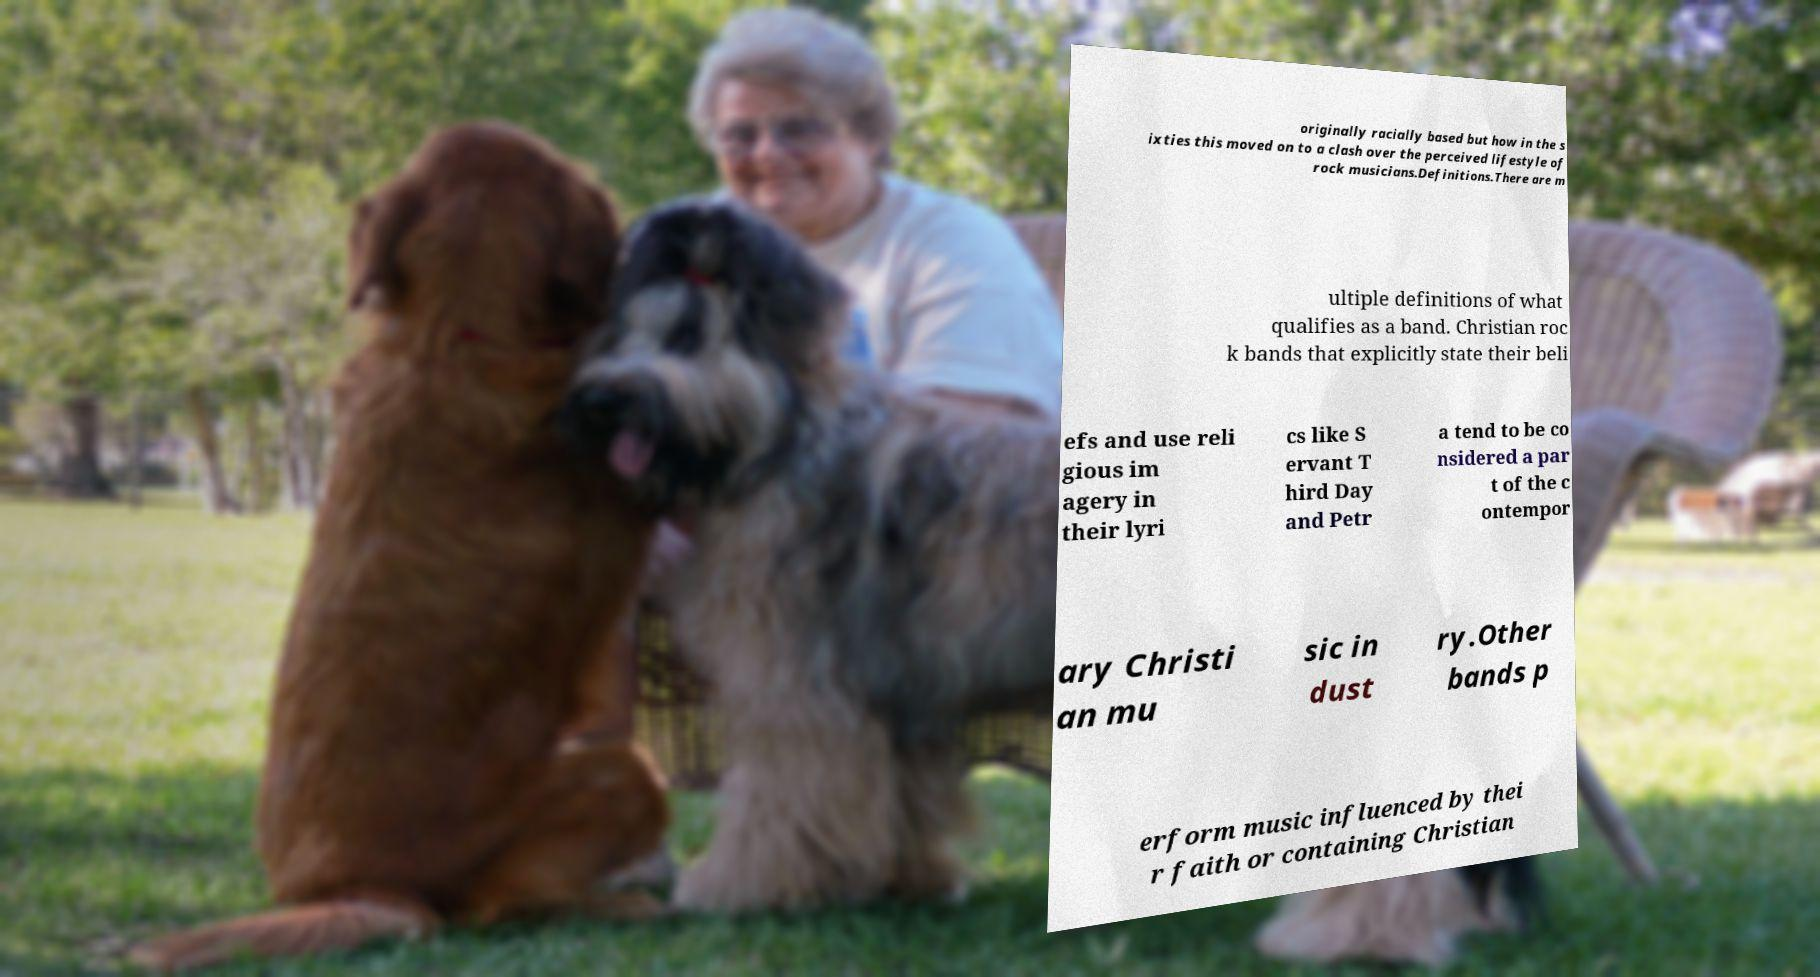Could you extract and type out the text from this image? originally racially based but how in the s ixties this moved on to a clash over the perceived lifestyle of rock musicians.Definitions.There are m ultiple definitions of what qualifies as a band. Christian roc k bands that explicitly state their beli efs and use reli gious im agery in their lyri cs like S ervant T hird Day and Petr a tend to be co nsidered a par t of the c ontempor ary Christi an mu sic in dust ry.Other bands p erform music influenced by thei r faith or containing Christian 